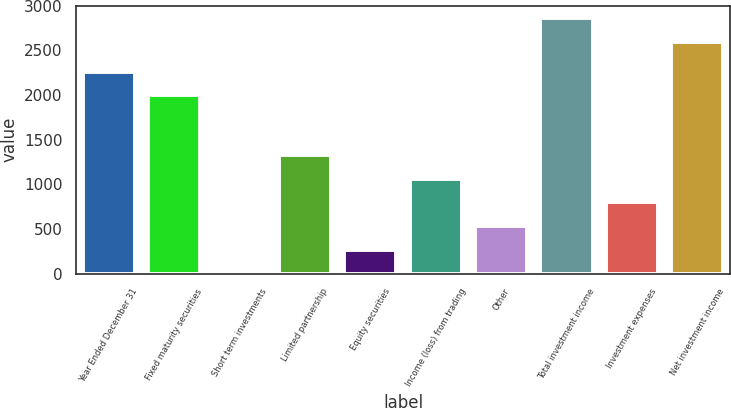Convert chart. <chart><loc_0><loc_0><loc_500><loc_500><bar_chart><fcel>Year Ended December 31<fcel>Fixed maturity securities<fcel>Short term investments<fcel>Limited partnership<fcel>Equity securities<fcel>Income (loss) from trading<fcel>Other<fcel>Total investment income<fcel>Investment expenses<fcel>Net investment income<nl><fcel>2262.4<fcel>1998<fcel>5<fcel>1327<fcel>269.4<fcel>1062.6<fcel>533.8<fcel>2857.4<fcel>798.2<fcel>2593<nl></chart> 